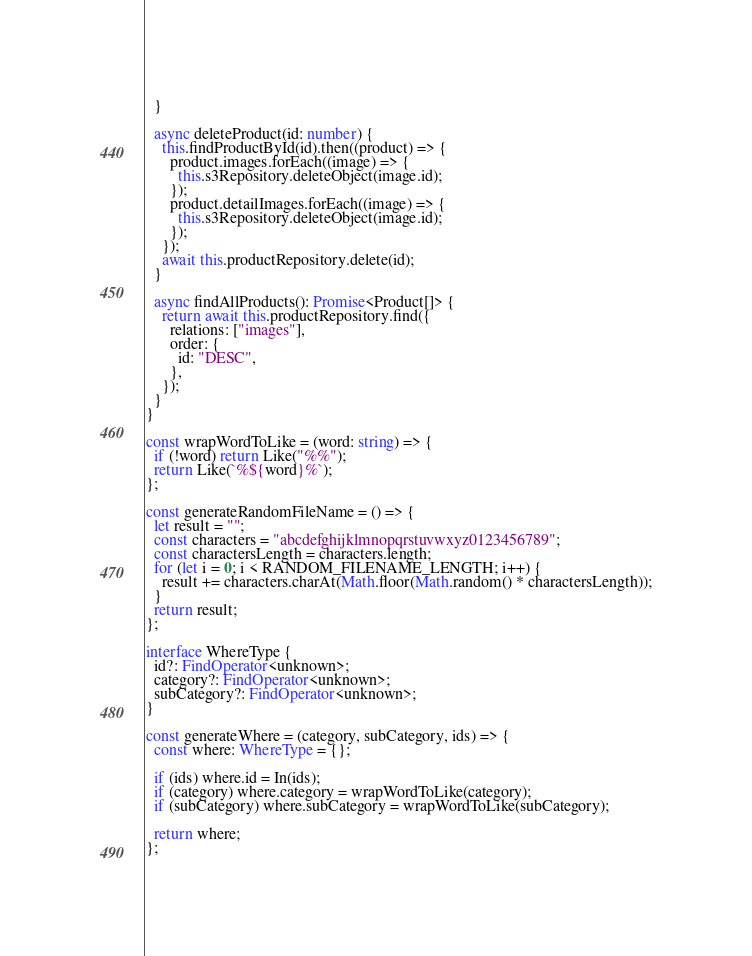Convert code to text. <code><loc_0><loc_0><loc_500><loc_500><_TypeScript_>  }

  async deleteProduct(id: number) {
    this.findProductById(id).then((product) => {
      product.images.forEach((image) => {
        this.s3Repository.deleteObject(image.id);
      });
      product.detailImages.forEach((image) => {
        this.s3Repository.deleteObject(image.id);
      });
    });
    await this.productRepository.delete(id);
  }

  async findAllProducts(): Promise<Product[]> {
    return await this.productRepository.find({
      relations: ["images"],
      order: {
        id: "DESC",
      },
    });
  }
}

const wrapWordToLike = (word: string) => {
  if (!word) return Like("%%");
  return Like(`%${word}%`);
};

const generateRandomFileName = () => {
  let result = "";
  const characters = "abcdefghijklmnopqrstuvwxyz0123456789";
  const charactersLength = characters.length;
  for (let i = 0; i < RANDOM_FILENAME_LENGTH; i++) {
    result += characters.charAt(Math.floor(Math.random() * charactersLength));
  }
  return result;
};

interface WhereType {
  id?: FindOperator<unknown>;
  category?: FindOperator<unknown>;
  subCategory?: FindOperator<unknown>;
}

const generateWhere = (category, subCategory, ids) => {
  const where: WhereType = {};

  if (ids) where.id = In(ids);
  if (category) where.category = wrapWordToLike(category);
  if (subCategory) where.subCategory = wrapWordToLike(subCategory);

  return where;
};
</code> 